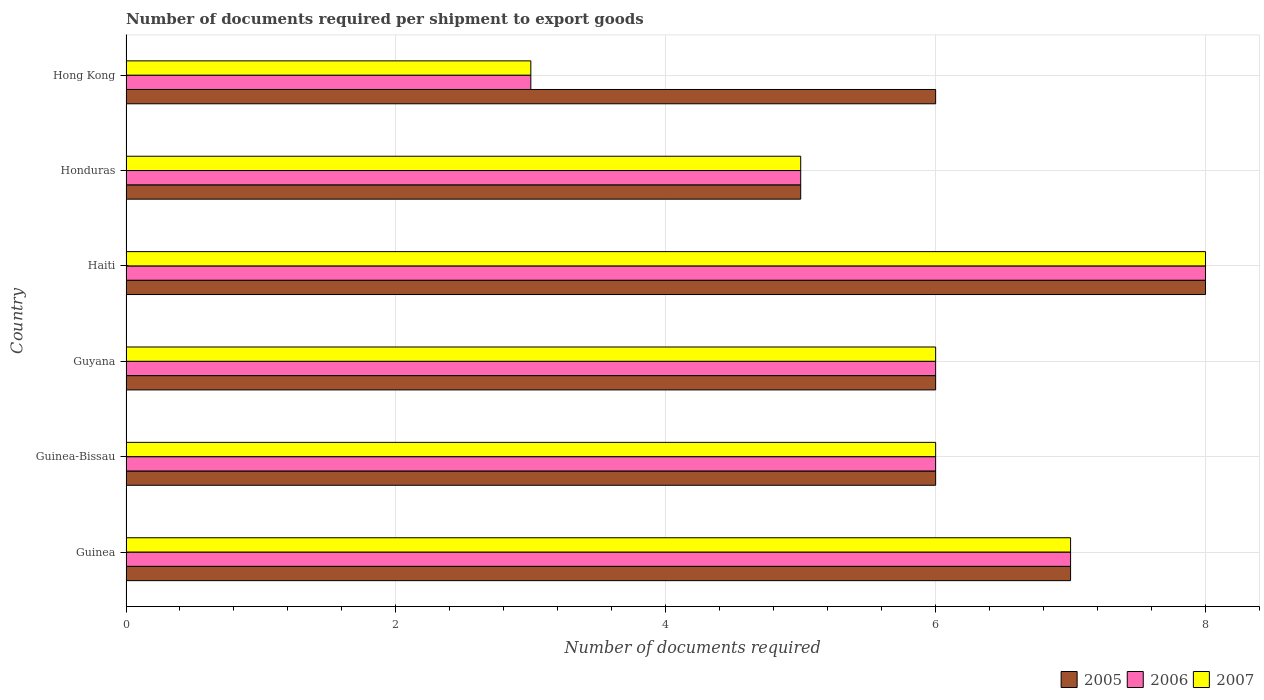How many different coloured bars are there?
Keep it short and to the point. 3. How many groups of bars are there?
Make the answer very short. 6. Are the number of bars per tick equal to the number of legend labels?
Keep it short and to the point. Yes. Are the number of bars on each tick of the Y-axis equal?
Ensure brevity in your answer.  Yes. What is the label of the 3rd group of bars from the top?
Provide a short and direct response. Haiti. In how many cases, is the number of bars for a given country not equal to the number of legend labels?
Provide a short and direct response. 0. What is the number of documents required per shipment to export goods in 2005 in Guinea?
Keep it short and to the point. 7. Across all countries, what is the minimum number of documents required per shipment to export goods in 2007?
Offer a terse response. 3. In which country was the number of documents required per shipment to export goods in 2007 maximum?
Ensure brevity in your answer.  Haiti. In which country was the number of documents required per shipment to export goods in 2006 minimum?
Your answer should be very brief. Hong Kong. What is the difference between the number of documents required per shipment to export goods in 2007 in Honduras and the number of documents required per shipment to export goods in 2006 in Haiti?
Offer a very short reply. -3. What is the average number of documents required per shipment to export goods in 2005 per country?
Offer a very short reply. 6.33. In how many countries, is the number of documents required per shipment to export goods in 2005 greater than 0.8 ?
Offer a terse response. 6. What is the ratio of the number of documents required per shipment to export goods in 2006 in Guinea to that in Haiti?
Your answer should be very brief. 0.88. What is the difference between the highest and the second highest number of documents required per shipment to export goods in 2005?
Your answer should be very brief. 1. In how many countries, is the number of documents required per shipment to export goods in 2005 greater than the average number of documents required per shipment to export goods in 2005 taken over all countries?
Ensure brevity in your answer.  2. Is the sum of the number of documents required per shipment to export goods in 2005 in Haiti and Honduras greater than the maximum number of documents required per shipment to export goods in 2006 across all countries?
Your answer should be very brief. Yes. What does the 3rd bar from the top in Guinea represents?
Make the answer very short. 2005. What does the 1st bar from the bottom in Guyana represents?
Give a very brief answer. 2005. Is it the case that in every country, the sum of the number of documents required per shipment to export goods in 2006 and number of documents required per shipment to export goods in 2005 is greater than the number of documents required per shipment to export goods in 2007?
Offer a very short reply. Yes. How many bars are there?
Offer a terse response. 18. Are all the bars in the graph horizontal?
Ensure brevity in your answer.  Yes. What is the difference between two consecutive major ticks on the X-axis?
Your answer should be very brief. 2. Are the values on the major ticks of X-axis written in scientific E-notation?
Offer a very short reply. No. Does the graph contain any zero values?
Your answer should be compact. No. Where does the legend appear in the graph?
Keep it short and to the point. Bottom right. How many legend labels are there?
Keep it short and to the point. 3. How are the legend labels stacked?
Ensure brevity in your answer.  Horizontal. What is the title of the graph?
Ensure brevity in your answer.  Number of documents required per shipment to export goods. What is the label or title of the X-axis?
Give a very brief answer. Number of documents required. What is the label or title of the Y-axis?
Offer a terse response. Country. What is the Number of documents required in 2007 in Guinea?
Make the answer very short. 7. What is the Number of documents required in 2007 in Guinea-Bissau?
Offer a terse response. 6. What is the Number of documents required of 2005 in Guyana?
Keep it short and to the point. 6. What is the Number of documents required in 2007 in Guyana?
Make the answer very short. 6. What is the Number of documents required in 2005 in Honduras?
Ensure brevity in your answer.  5. What is the Number of documents required of 2006 in Hong Kong?
Offer a very short reply. 3. Across all countries, what is the maximum Number of documents required in 2006?
Make the answer very short. 8. Across all countries, what is the maximum Number of documents required in 2007?
Your answer should be very brief. 8. Across all countries, what is the minimum Number of documents required in 2005?
Offer a terse response. 5. Across all countries, what is the minimum Number of documents required in 2006?
Make the answer very short. 3. Across all countries, what is the minimum Number of documents required in 2007?
Your answer should be very brief. 3. What is the difference between the Number of documents required in 2005 in Guinea and that in Guinea-Bissau?
Provide a short and direct response. 1. What is the difference between the Number of documents required of 2007 in Guinea and that in Guinea-Bissau?
Offer a terse response. 1. What is the difference between the Number of documents required in 2005 in Guinea and that in Guyana?
Ensure brevity in your answer.  1. What is the difference between the Number of documents required in 2007 in Guinea and that in Guyana?
Provide a succinct answer. 1. What is the difference between the Number of documents required in 2007 in Guinea and that in Haiti?
Provide a short and direct response. -1. What is the difference between the Number of documents required of 2005 in Guinea and that in Honduras?
Offer a terse response. 2. What is the difference between the Number of documents required in 2006 in Guinea and that in Hong Kong?
Make the answer very short. 4. What is the difference between the Number of documents required in 2006 in Guinea-Bissau and that in Haiti?
Your response must be concise. -2. What is the difference between the Number of documents required in 2007 in Guinea-Bissau and that in Haiti?
Provide a short and direct response. -2. What is the difference between the Number of documents required of 2006 in Guinea-Bissau and that in Honduras?
Your answer should be compact. 1. What is the difference between the Number of documents required in 2006 in Guinea-Bissau and that in Hong Kong?
Give a very brief answer. 3. What is the difference between the Number of documents required of 2007 in Guinea-Bissau and that in Hong Kong?
Your response must be concise. 3. What is the difference between the Number of documents required of 2005 in Guyana and that in Haiti?
Provide a short and direct response. -2. What is the difference between the Number of documents required of 2007 in Guyana and that in Honduras?
Provide a short and direct response. 1. What is the difference between the Number of documents required in 2005 in Guyana and that in Hong Kong?
Your answer should be very brief. 0. What is the difference between the Number of documents required in 2005 in Haiti and that in Honduras?
Your response must be concise. 3. What is the difference between the Number of documents required in 2006 in Haiti and that in Honduras?
Give a very brief answer. 3. What is the difference between the Number of documents required of 2007 in Haiti and that in Hong Kong?
Make the answer very short. 5. What is the difference between the Number of documents required in 2005 in Guinea and the Number of documents required in 2006 in Guyana?
Offer a terse response. 1. What is the difference between the Number of documents required of 2005 in Guinea and the Number of documents required of 2006 in Haiti?
Ensure brevity in your answer.  -1. What is the difference between the Number of documents required of 2005 in Guinea and the Number of documents required of 2007 in Honduras?
Your answer should be compact. 2. What is the difference between the Number of documents required of 2006 in Guinea and the Number of documents required of 2007 in Hong Kong?
Your answer should be very brief. 4. What is the difference between the Number of documents required in 2005 in Guinea-Bissau and the Number of documents required in 2007 in Guyana?
Provide a short and direct response. 0. What is the difference between the Number of documents required of 2005 in Guinea-Bissau and the Number of documents required of 2006 in Haiti?
Offer a very short reply. -2. What is the difference between the Number of documents required of 2005 in Guinea-Bissau and the Number of documents required of 2006 in Honduras?
Your answer should be compact. 1. What is the difference between the Number of documents required in 2005 in Guinea-Bissau and the Number of documents required in 2007 in Honduras?
Provide a succinct answer. 1. What is the difference between the Number of documents required in 2006 in Guinea-Bissau and the Number of documents required in 2007 in Honduras?
Offer a very short reply. 1. What is the difference between the Number of documents required in 2005 in Guinea-Bissau and the Number of documents required in 2006 in Hong Kong?
Your response must be concise. 3. What is the difference between the Number of documents required in 2005 in Guinea-Bissau and the Number of documents required in 2007 in Hong Kong?
Make the answer very short. 3. What is the difference between the Number of documents required in 2005 in Guyana and the Number of documents required in 2007 in Haiti?
Keep it short and to the point. -2. What is the difference between the Number of documents required of 2006 in Guyana and the Number of documents required of 2007 in Haiti?
Keep it short and to the point. -2. What is the difference between the Number of documents required in 2005 in Guyana and the Number of documents required in 2006 in Honduras?
Offer a very short reply. 1. What is the difference between the Number of documents required of 2006 in Guyana and the Number of documents required of 2007 in Honduras?
Offer a very short reply. 1. What is the difference between the Number of documents required in 2005 in Haiti and the Number of documents required in 2006 in Hong Kong?
Keep it short and to the point. 5. What is the average Number of documents required of 2005 per country?
Offer a terse response. 6.33. What is the average Number of documents required in 2006 per country?
Keep it short and to the point. 5.83. What is the average Number of documents required of 2007 per country?
Make the answer very short. 5.83. What is the difference between the Number of documents required of 2005 and Number of documents required of 2006 in Guinea?
Offer a terse response. 0. What is the difference between the Number of documents required of 2005 and Number of documents required of 2007 in Guinea?
Your answer should be very brief. 0. What is the difference between the Number of documents required in 2005 and Number of documents required in 2006 in Haiti?
Offer a terse response. 0. What is the difference between the Number of documents required of 2005 and Number of documents required of 2007 in Haiti?
Offer a terse response. 0. What is the difference between the Number of documents required in 2006 and Number of documents required in 2007 in Hong Kong?
Provide a succinct answer. 0. What is the ratio of the Number of documents required of 2006 in Guinea to that in Guinea-Bissau?
Ensure brevity in your answer.  1.17. What is the ratio of the Number of documents required of 2006 in Guinea to that in Guyana?
Give a very brief answer. 1.17. What is the ratio of the Number of documents required of 2007 in Guinea to that in Guyana?
Your answer should be compact. 1.17. What is the ratio of the Number of documents required in 2006 in Guinea to that in Honduras?
Your answer should be compact. 1.4. What is the ratio of the Number of documents required in 2006 in Guinea to that in Hong Kong?
Ensure brevity in your answer.  2.33. What is the ratio of the Number of documents required in 2007 in Guinea to that in Hong Kong?
Your response must be concise. 2.33. What is the ratio of the Number of documents required in 2006 in Guinea-Bissau to that in Guyana?
Provide a succinct answer. 1. What is the ratio of the Number of documents required in 2006 in Guinea-Bissau to that in Haiti?
Give a very brief answer. 0.75. What is the ratio of the Number of documents required of 2007 in Guinea-Bissau to that in Haiti?
Give a very brief answer. 0.75. What is the ratio of the Number of documents required in 2005 in Guinea-Bissau to that in Honduras?
Make the answer very short. 1.2. What is the ratio of the Number of documents required of 2007 in Guinea-Bissau to that in Honduras?
Your answer should be compact. 1.2. What is the ratio of the Number of documents required in 2006 in Guinea-Bissau to that in Hong Kong?
Make the answer very short. 2. What is the ratio of the Number of documents required of 2007 in Guinea-Bissau to that in Hong Kong?
Your response must be concise. 2. What is the ratio of the Number of documents required in 2005 in Guyana to that in Haiti?
Your answer should be compact. 0.75. What is the ratio of the Number of documents required of 2007 in Guyana to that in Haiti?
Offer a very short reply. 0.75. What is the ratio of the Number of documents required of 2005 in Guyana to that in Honduras?
Keep it short and to the point. 1.2. What is the ratio of the Number of documents required in 2007 in Guyana to that in Honduras?
Your response must be concise. 1.2. What is the ratio of the Number of documents required in 2005 in Guyana to that in Hong Kong?
Ensure brevity in your answer.  1. What is the ratio of the Number of documents required in 2006 in Guyana to that in Hong Kong?
Offer a terse response. 2. What is the ratio of the Number of documents required in 2007 in Guyana to that in Hong Kong?
Give a very brief answer. 2. What is the ratio of the Number of documents required of 2005 in Haiti to that in Honduras?
Provide a succinct answer. 1.6. What is the ratio of the Number of documents required of 2006 in Haiti to that in Honduras?
Provide a short and direct response. 1.6. What is the ratio of the Number of documents required of 2007 in Haiti to that in Honduras?
Offer a terse response. 1.6. What is the ratio of the Number of documents required in 2005 in Haiti to that in Hong Kong?
Provide a short and direct response. 1.33. What is the ratio of the Number of documents required in 2006 in Haiti to that in Hong Kong?
Ensure brevity in your answer.  2.67. What is the ratio of the Number of documents required of 2007 in Haiti to that in Hong Kong?
Your answer should be very brief. 2.67. What is the difference between the highest and the second highest Number of documents required in 2005?
Give a very brief answer. 1. What is the difference between the highest and the second highest Number of documents required of 2006?
Provide a short and direct response. 1. What is the difference between the highest and the lowest Number of documents required in 2005?
Give a very brief answer. 3. What is the difference between the highest and the lowest Number of documents required of 2006?
Give a very brief answer. 5. What is the difference between the highest and the lowest Number of documents required of 2007?
Offer a terse response. 5. 